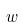<formula> <loc_0><loc_0><loc_500><loc_500>w</formula> 